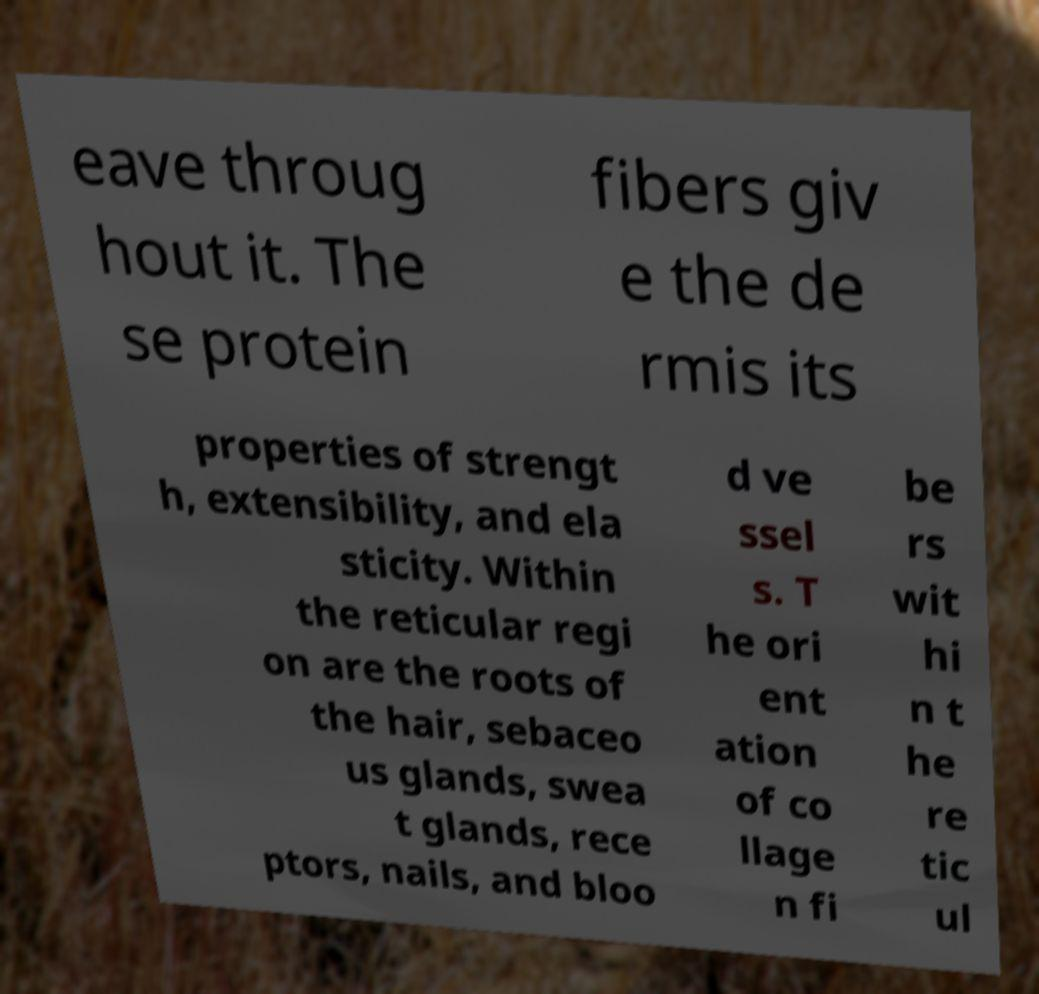Could you extract and type out the text from this image? eave throug hout it. The se protein fibers giv e the de rmis its properties of strengt h, extensibility, and ela sticity. Within the reticular regi on are the roots of the hair, sebaceo us glands, swea t glands, rece ptors, nails, and bloo d ve ssel s. T he ori ent ation of co llage n fi be rs wit hi n t he re tic ul 